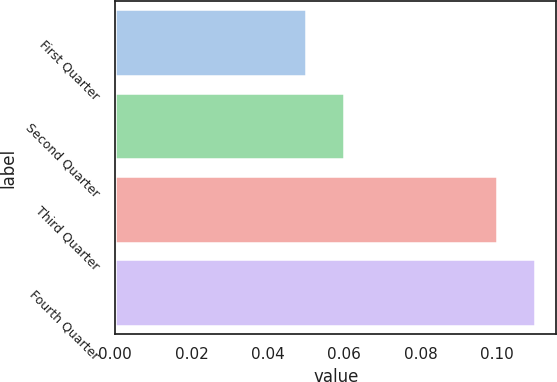Convert chart. <chart><loc_0><loc_0><loc_500><loc_500><bar_chart><fcel>First Quarter<fcel>Second Quarter<fcel>Third Quarter<fcel>Fourth Quarter<nl><fcel>0.05<fcel>0.06<fcel>0.1<fcel>0.11<nl></chart> 